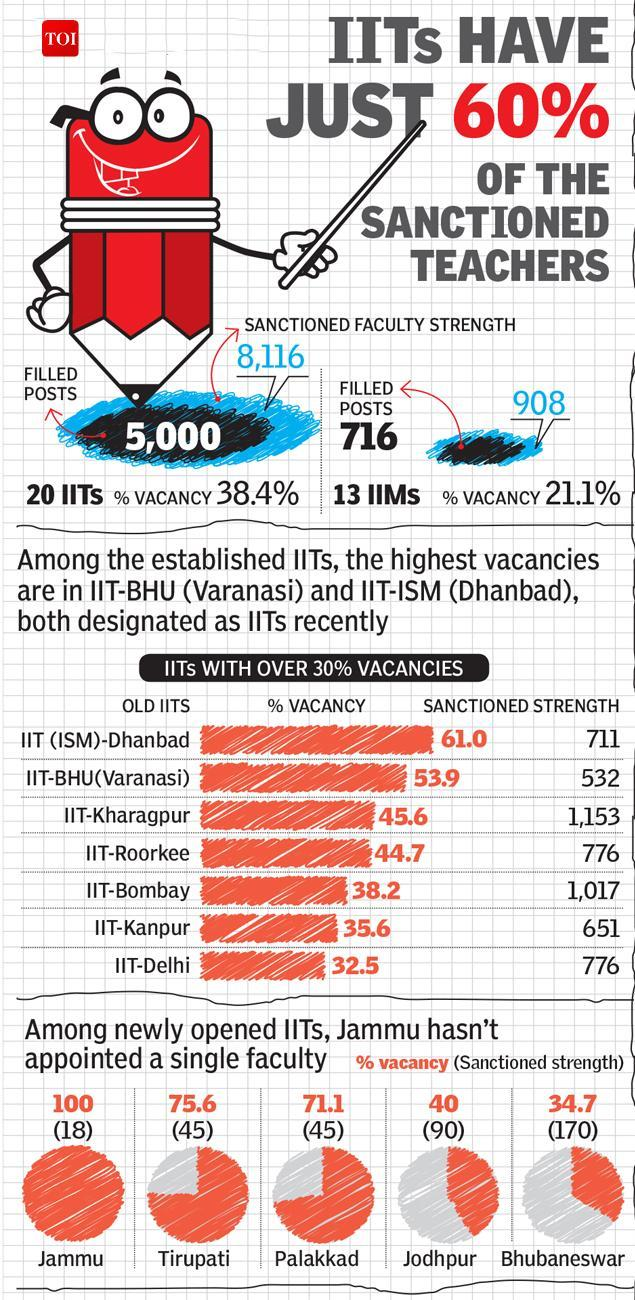Which IIT has above 60% of faculty vacancy?
Answer the question with a short phrase. IIT (ISM)-Dhanbad What is the percentage faculty vacancy at IIT, Tirupati? 75.6 How many faculty posts are filled in 20 IITs? 5,000 Which IIT has below 35% of faculty vacancy? IIT-Delhi What is the sanctioned faculty strength in 13 IIMS? 908 What is the sanctioned faculty strength in IIT-Bombay? 1,017 What is the percentage faculty vacancy at IIT, Palakkad? 71.1 